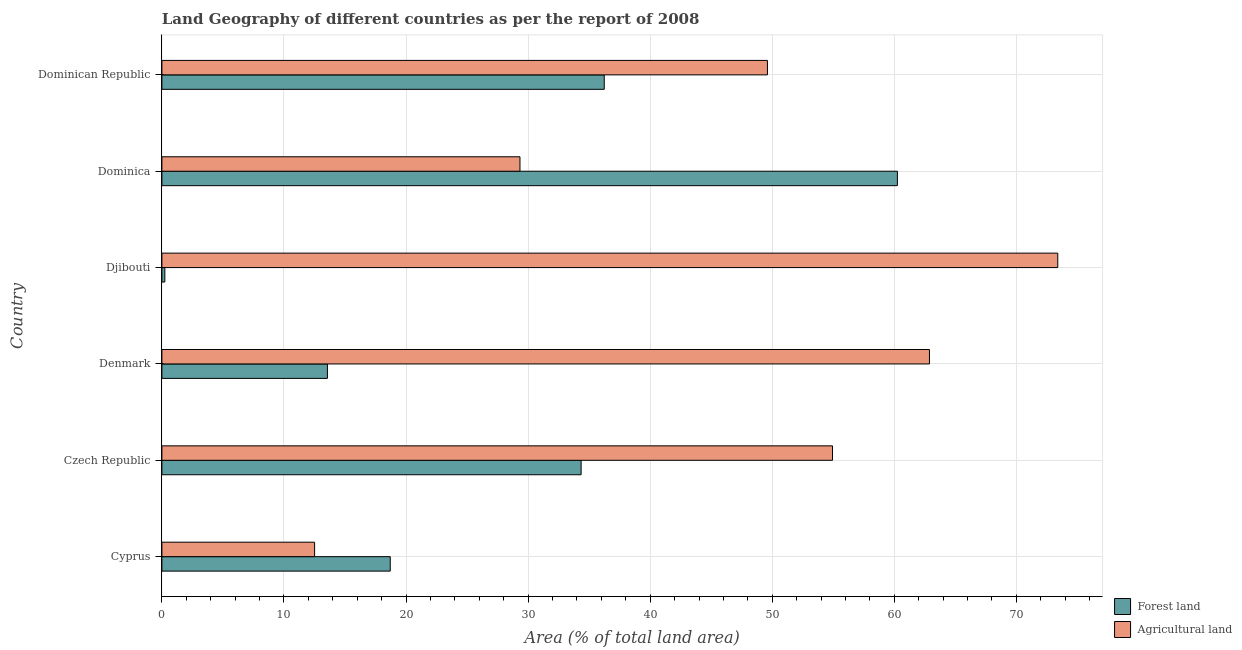Are the number of bars per tick equal to the number of legend labels?
Provide a short and direct response. Yes. What is the label of the 1st group of bars from the top?
Provide a succinct answer. Dominican Republic. In how many cases, is the number of bars for a given country not equal to the number of legend labels?
Offer a very short reply. 0. What is the percentage of land area under agriculture in Cyprus?
Make the answer very short. 12.51. Across all countries, what is the maximum percentage of land area under agriculture?
Offer a terse response. 73.39. Across all countries, what is the minimum percentage of land area under agriculture?
Make the answer very short. 12.51. In which country was the percentage of land area under forests maximum?
Provide a short and direct response. Dominica. In which country was the percentage of land area under agriculture minimum?
Ensure brevity in your answer.  Cyprus. What is the total percentage of land area under agriculture in the graph?
Ensure brevity in your answer.  282.66. What is the difference between the percentage of land area under forests in Cyprus and that in Denmark?
Your response must be concise. 5.15. What is the difference between the percentage of land area under forests in Dominican Republic and the percentage of land area under agriculture in Dominica?
Your response must be concise. 6.9. What is the average percentage of land area under forests per country?
Provide a succinct answer. 27.22. What is the difference between the percentage of land area under forests and percentage of land area under agriculture in Dominican Republic?
Make the answer very short. -13.37. In how many countries, is the percentage of land area under forests greater than 68 %?
Provide a short and direct response. 0. What is the ratio of the percentage of land area under forests in Djibouti to that in Dominican Republic?
Make the answer very short. 0.01. Is the percentage of land area under agriculture in Cyprus less than that in Djibouti?
Make the answer very short. Yes. Is the difference between the percentage of land area under forests in Czech Republic and Djibouti greater than the difference between the percentage of land area under agriculture in Czech Republic and Djibouti?
Your answer should be very brief. Yes. What is the difference between the highest and the second highest percentage of land area under agriculture?
Offer a terse response. 10.51. What is the difference between the highest and the lowest percentage of land area under agriculture?
Provide a short and direct response. 60.88. In how many countries, is the percentage of land area under forests greater than the average percentage of land area under forests taken over all countries?
Provide a succinct answer. 3. What does the 1st bar from the top in Djibouti represents?
Offer a very short reply. Agricultural land. What does the 2nd bar from the bottom in Djibouti represents?
Provide a succinct answer. Agricultural land. Does the graph contain grids?
Your response must be concise. Yes. Where does the legend appear in the graph?
Give a very brief answer. Bottom right. How many legend labels are there?
Your response must be concise. 2. How are the legend labels stacked?
Provide a short and direct response. Vertical. What is the title of the graph?
Your answer should be compact. Land Geography of different countries as per the report of 2008. What is the label or title of the X-axis?
Offer a terse response. Area (% of total land area). What is the Area (% of total land area) of Forest land in Cyprus?
Give a very brief answer. 18.71. What is the Area (% of total land area) in Agricultural land in Cyprus?
Keep it short and to the point. 12.51. What is the Area (% of total land area) in Forest land in Czech Republic?
Provide a succinct answer. 34.34. What is the Area (% of total land area) in Agricultural land in Czech Republic?
Your response must be concise. 54.94. What is the Area (% of total land area) of Forest land in Denmark?
Provide a succinct answer. 13.56. What is the Area (% of total land area) in Agricultural land in Denmark?
Your answer should be very brief. 62.88. What is the Area (% of total land area) of Forest land in Djibouti?
Ensure brevity in your answer.  0.24. What is the Area (% of total land area) of Agricultural land in Djibouti?
Your response must be concise. 73.39. What is the Area (% of total land area) in Forest land in Dominica?
Keep it short and to the point. 60.25. What is the Area (% of total land area) of Agricultural land in Dominica?
Offer a terse response. 29.33. What is the Area (% of total land area) in Forest land in Dominican Republic?
Provide a short and direct response. 36.24. What is the Area (% of total land area) of Agricultural land in Dominican Republic?
Offer a very short reply. 49.61. Across all countries, what is the maximum Area (% of total land area) in Forest land?
Provide a succinct answer. 60.25. Across all countries, what is the maximum Area (% of total land area) in Agricultural land?
Your answer should be very brief. 73.39. Across all countries, what is the minimum Area (% of total land area) of Forest land?
Your answer should be compact. 0.24. Across all countries, what is the minimum Area (% of total land area) of Agricultural land?
Your response must be concise. 12.51. What is the total Area (% of total land area) in Forest land in the graph?
Your answer should be compact. 163.34. What is the total Area (% of total land area) of Agricultural land in the graph?
Give a very brief answer. 282.66. What is the difference between the Area (% of total land area) in Forest land in Cyprus and that in Czech Republic?
Provide a succinct answer. -15.64. What is the difference between the Area (% of total land area) of Agricultural land in Cyprus and that in Czech Republic?
Offer a very short reply. -42.43. What is the difference between the Area (% of total land area) of Forest land in Cyprus and that in Denmark?
Provide a short and direct response. 5.15. What is the difference between the Area (% of total land area) in Agricultural land in Cyprus and that in Denmark?
Provide a succinct answer. -50.37. What is the difference between the Area (% of total land area) of Forest land in Cyprus and that in Djibouti?
Offer a very short reply. 18.47. What is the difference between the Area (% of total land area) in Agricultural land in Cyprus and that in Djibouti?
Offer a very short reply. -60.88. What is the difference between the Area (% of total land area) of Forest land in Cyprus and that in Dominica?
Your answer should be compact. -41.55. What is the difference between the Area (% of total land area) of Agricultural land in Cyprus and that in Dominica?
Offer a terse response. -16.82. What is the difference between the Area (% of total land area) of Forest land in Cyprus and that in Dominican Republic?
Provide a succinct answer. -17.53. What is the difference between the Area (% of total land area) of Agricultural land in Cyprus and that in Dominican Republic?
Give a very brief answer. -37.1. What is the difference between the Area (% of total land area) in Forest land in Czech Republic and that in Denmark?
Make the answer very short. 20.78. What is the difference between the Area (% of total land area) in Agricultural land in Czech Republic and that in Denmark?
Your answer should be compact. -7.94. What is the difference between the Area (% of total land area) of Forest land in Czech Republic and that in Djibouti?
Ensure brevity in your answer.  34.1. What is the difference between the Area (% of total land area) of Agricultural land in Czech Republic and that in Djibouti?
Provide a succinct answer. -18.45. What is the difference between the Area (% of total land area) in Forest land in Czech Republic and that in Dominica?
Make the answer very short. -25.91. What is the difference between the Area (% of total land area) in Agricultural land in Czech Republic and that in Dominica?
Keep it short and to the point. 25.61. What is the difference between the Area (% of total land area) in Forest land in Czech Republic and that in Dominican Republic?
Ensure brevity in your answer.  -1.89. What is the difference between the Area (% of total land area) of Agricultural land in Czech Republic and that in Dominican Republic?
Your answer should be compact. 5.33. What is the difference between the Area (% of total land area) in Forest land in Denmark and that in Djibouti?
Make the answer very short. 13.32. What is the difference between the Area (% of total land area) of Agricultural land in Denmark and that in Djibouti?
Your answer should be very brief. -10.51. What is the difference between the Area (% of total land area) of Forest land in Denmark and that in Dominica?
Your response must be concise. -46.69. What is the difference between the Area (% of total land area) of Agricultural land in Denmark and that in Dominica?
Give a very brief answer. 33.55. What is the difference between the Area (% of total land area) in Forest land in Denmark and that in Dominican Republic?
Your answer should be compact. -22.68. What is the difference between the Area (% of total land area) of Agricultural land in Denmark and that in Dominican Republic?
Provide a succinct answer. 13.27. What is the difference between the Area (% of total land area) in Forest land in Djibouti and that in Dominica?
Your answer should be very brief. -60.01. What is the difference between the Area (% of total land area) of Agricultural land in Djibouti and that in Dominica?
Your response must be concise. 44.06. What is the difference between the Area (% of total land area) of Forest land in Djibouti and that in Dominican Republic?
Offer a very short reply. -36. What is the difference between the Area (% of total land area) of Agricultural land in Djibouti and that in Dominican Republic?
Offer a very short reply. 23.78. What is the difference between the Area (% of total land area) in Forest land in Dominica and that in Dominican Republic?
Your response must be concise. 24.02. What is the difference between the Area (% of total land area) in Agricultural land in Dominica and that in Dominican Republic?
Your response must be concise. -20.27. What is the difference between the Area (% of total land area) in Forest land in Cyprus and the Area (% of total land area) in Agricultural land in Czech Republic?
Ensure brevity in your answer.  -36.23. What is the difference between the Area (% of total land area) in Forest land in Cyprus and the Area (% of total land area) in Agricultural land in Denmark?
Make the answer very short. -44.17. What is the difference between the Area (% of total land area) in Forest land in Cyprus and the Area (% of total land area) in Agricultural land in Djibouti?
Make the answer very short. -54.68. What is the difference between the Area (% of total land area) in Forest land in Cyprus and the Area (% of total land area) in Agricultural land in Dominica?
Your answer should be very brief. -10.63. What is the difference between the Area (% of total land area) of Forest land in Cyprus and the Area (% of total land area) of Agricultural land in Dominican Republic?
Offer a very short reply. -30.9. What is the difference between the Area (% of total land area) in Forest land in Czech Republic and the Area (% of total land area) in Agricultural land in Denmark?
Ensure brevity in your answer.  -28.54. What is the difference between the Area (% of total land area) in Forest land in Czech Republic and the Area (% of total land area) in Agricultural land in Djibouti?
Your answer should be compact. -39.05. What is the difference between the Area (% of total land area) of Forest land in Czech Republic and the Area (% of total land area) of Agricultural land in Dominica?
Keep it short and to the point. 5.01. What is the difference between the Area (% of total land area) of Forest land in Czech Republic and the Area (% of total land area) of Agricultural land in Dominican Republic?
Provide a succinct answer. -15.26. What is the difference between the Area (% of total land area) of Forest land in Denmark and the Area (% of total land area) of Agricultural land in Djibouti?
Offer a terse response. -59.83. What is the difference between the Area (% of total land area) in Forest land in Denmark and the Area (% of total land area) in Agricultural land in Dominica?
Provide a short and direct response. -15.77. What is the difference between the Area (% of total land area) in Forest land in Denmark and the Area (% of total land area) in Agricultural land in Dominican Republic?
Offer a very short reply. -36.05. What is the difference between the Area (% of total land area) in Forest land in Djibouti and the Area (% of total land area) in Agricultural land in Dominica?
Keep it short and to the point. -29.09. What is the difference between the Area (% of total land area) in Forest land in Djibouti and the Area (% of total land area) in Agricultural land in Dominican Republic?
Provide a short and direct response. -49.37. What is the difference between the Area (% of total land area) in Forest land in Dominica and the Area (% of total land area) in Agricultural land in Dominican Republic?
Offer a very short reply. 10.65. What is the average Area (% of total land area) of Forest land per country?
Offer a very short reply. 27.22. What is the average Area (% of total land area) of Agricultural land per country?
Your answer should be very brief. 47.11. What is the difference between the Area (% of total land area) in Forest land and Area (% of total land area) in Agricultural land in Cyprus?
Keep it short and to the point. 6.2. What is the difference between the Area (% of total land area) of Forest land and Area (% of total land area) of Agricultural land in Czech Republic?
Your response must be concise. -20.6. What is the difference between the Area (% of total land area) of Forest land and Area (% of total land area) of Agricultural land in Denmark?
Your answer should be very brief. -49.32. What is the difference between the Area (% of total land area) of Forest land and Area (% of total land area) of Agricultural land in Djibouti?
Make the answer very short. -73.15. What is the difference between the Area (% of total land area) of Forest land and Area (% of total land area) of Agricultural land in Dominica?
Offer a very short reply. 30.92. What is the difference between the Area (% of total land area) in Forest land and Area (% of total land area) in Agricultural land in Dominican Republic?
Make the answer very short. -13.37. What is the ratio of the Area (% of total land area) in Forest land in Cyprus to that in Czech Republic?
Give a very brief answer. 0.54. What is the ratio of the Area (% of total land area) in Agricultural land in Cyprus to that in Czech Republic?
Give a very brief answer. 0.23. What is the ratio of the Area (% of total land area) in Forest land in Cyprus to that in Denmark?
Offer a terse response. 1.38. What is the ratio of the Area (% of total land area) in Agricultural land in Cyprus to that in Denmark?
Your answer should be compact. 0.2. What is the ratio of the Area (% of total land area) of Forest land in Cyprus to that in Djibouti?
Your answer should be compact. 77.43. What is the ratio of the Area (% of total land area) in Agricultural land in Cyprus to that in Djibouti?
Your response must be concise. 0.17. What is the ratio of the Area (% of total land area) in Forest land in Cyprus to that in Dominica?
Provide a succinct answer. 0.31. What is the ratio of the Area (% of total land area) in Agricultural land in Cyprus to that in Dominica?
Your response must be concise. 0.43. What is the ratio of the Area (% of total land area) in Forest land in Cyprus to that in Dominican Republic?
Your answer should be compact. 0.52. What is the ratio of the Area (% of total land area) in Agricultural land in Cyprus to that in Dominican Republic?
Offer a terse response. 0.25. What is the ratio of the Area (% of total land area) of Forest land in Czech Republic to that in Denmark?
Keep it short and to the point. 2.53. What is the ratio of the Area (% of total land area) of Agricultural land in Czech Republic to that in Denmark?
Your answer should be very brief. 0.87. What is the ratio of the Area (% of total land area) in Forest land in Czech Republic to that in Djibouti?
Offer a very short reply. 142.16. What is the ratio of the Area (% of total land area) in Agricultural land in Czech Republic to that in Djibouti?
Offer a very short reply. 0.75. What is the ratio of the Area (% of total land area) of Forest land in Czech Republic to that in Dominica?
Your answer should be very brief. 0.57. What is the ratio of the Area (% of total land area) in Agricultural land in Czech Republic to that in Dominica?
Offer a very short reply. 1.87. What is the ratio of the Area (% of total land area) in Forest land in Czech Republic to that in Dominican Republic?
Your response must be concise. 0.95. What is the ratio of the Area (% of total land area) of Agricultural land in Czech Republic to that in Dominican Republic?
Ensure brevity in your answer.  1.11. What is the ratio of the Area (% of total land area) in Forest land in Denmark to that in Djibouti?
Provide a succinct answer. 56.13. What is the ratio of the Area (% of total land area) in Agricultural land in Denmark to that in Djibouti?
Your response must be concise. 0.86. What is the ratio of the Area (% of total land area) in Forest land in Denmark to that in Dominica?
Provide a short and direct response. 0.23. What is the ratio of the Area (% of total land area) in Agricultural land in Denmark to that in Dominica?
Provide a succinct answer. 2.14. What is the ratio of the Area (% of total land area) of Forest land in Denmark to that in Dominican Republic?
Provide a short and direct response. 0.37. What is the ratio of the Area (% of total land area) in Agricultural land in Denmark to that in Dominican Republic?
Provide a succinct answer. 1.27. What is the ratio of the Area (% of total land area) in Forest land in Djibouti to that in Dominica?
Your answer should be very brief. 0. What is the ratio of the Area (% of total land area) of Agricultural land in Djibouti to that in Dominica?
Your answer should be compact. 2.5. What is the ratio of the Area (% of total land area) in Forest land in Djibouti to that in Dominican Republic?
Give a very brief answer. 0.01. What is the ratio of the Area (% of total land area) of Agricultural land in Djibouti to that in Dominican Republic?
Ensure brevity in your answer.  1.48. What is the ratio of the Area (% of total land area) of Forest land in Dominica to that in Dominican Republic?
Keep it short and to the point. 1.66. What is the ratio of the Area (% of total land area) in Agricultural land in Dominica to that in Dominican Republic?
Make the answer very short. 0.59. What is the difference between the highest and the second highest Area (% of total land area) of Forest land?
Ensure brevity in your answer.  24.02. What is the difference between the highest and the second highest Area (% of total land area) of Agricultural land?
Make the answer very short. 10.51. What is the difference between the highest and the lowest Area (% of total land area) of Forest land?
Ensure brevity in your answer.  60.01. What is the difference between the highest and the lowest Area (% of total land area) of Agricultural land?
Your answer should be compact. 60.88. 